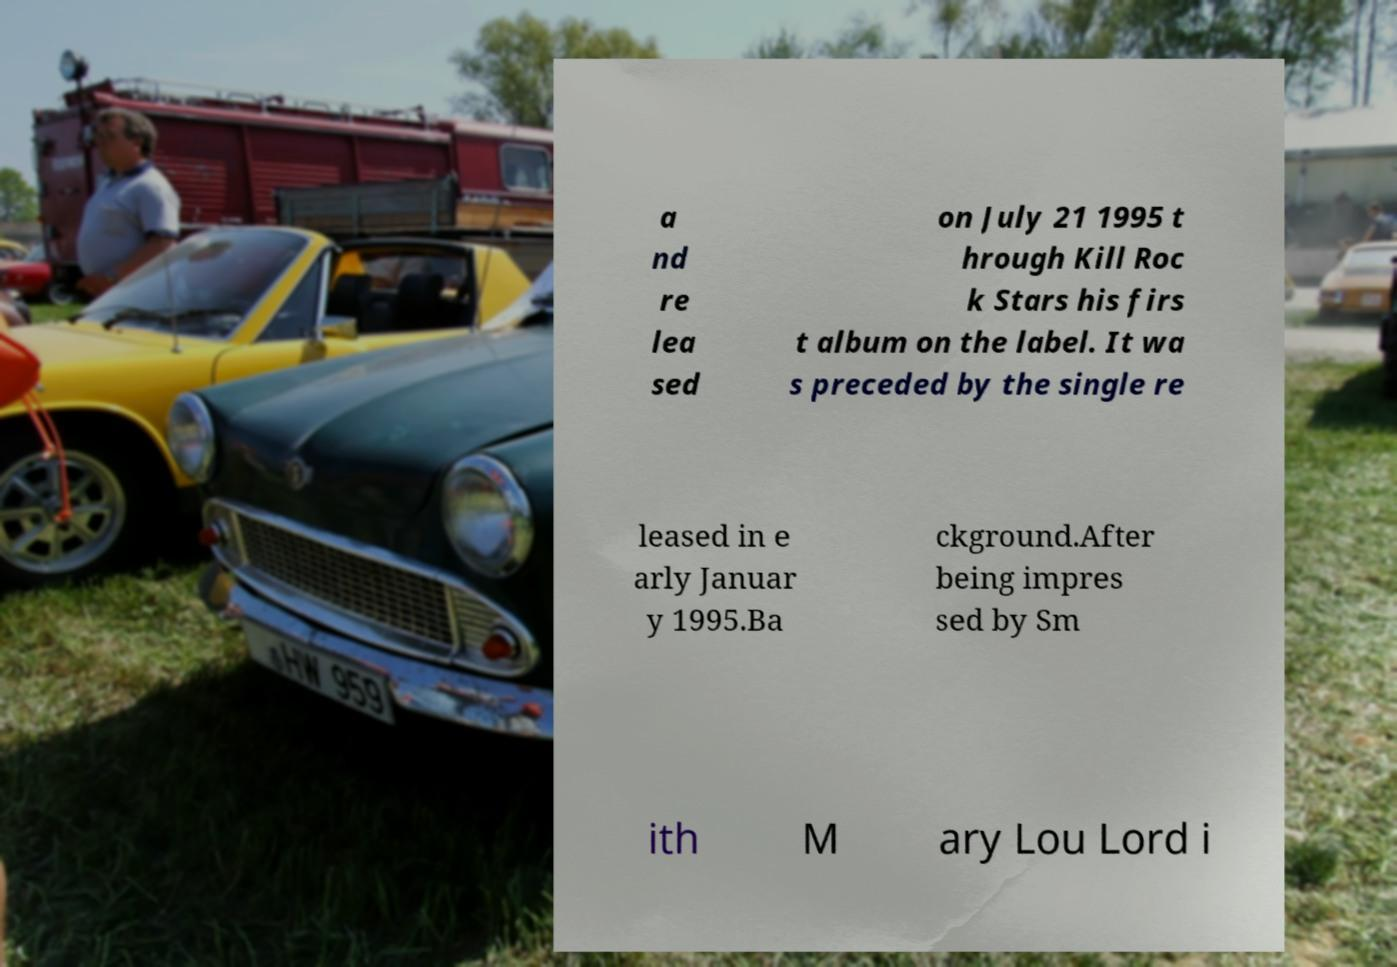I need the written content from this picture converted into text. Can you do that? a nd re lea sed on July 21 1995 t hrough Kill Roc k Stars his firs t album on the label. It wa s preceded by the single re leased in e arly Januar y 1995.Ba ckground.After being impres sed by Sm ith M ary Lou Lord i 